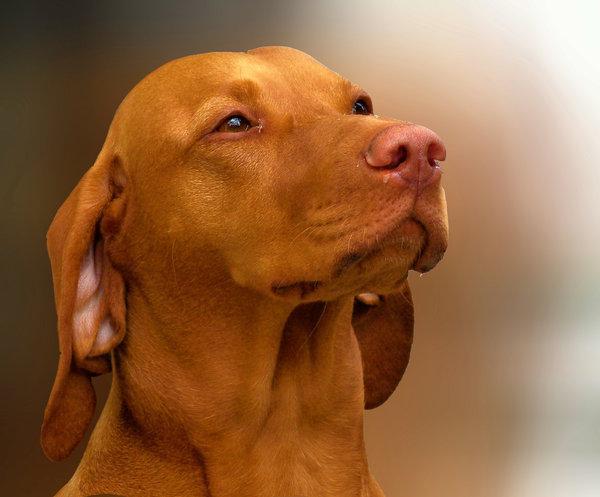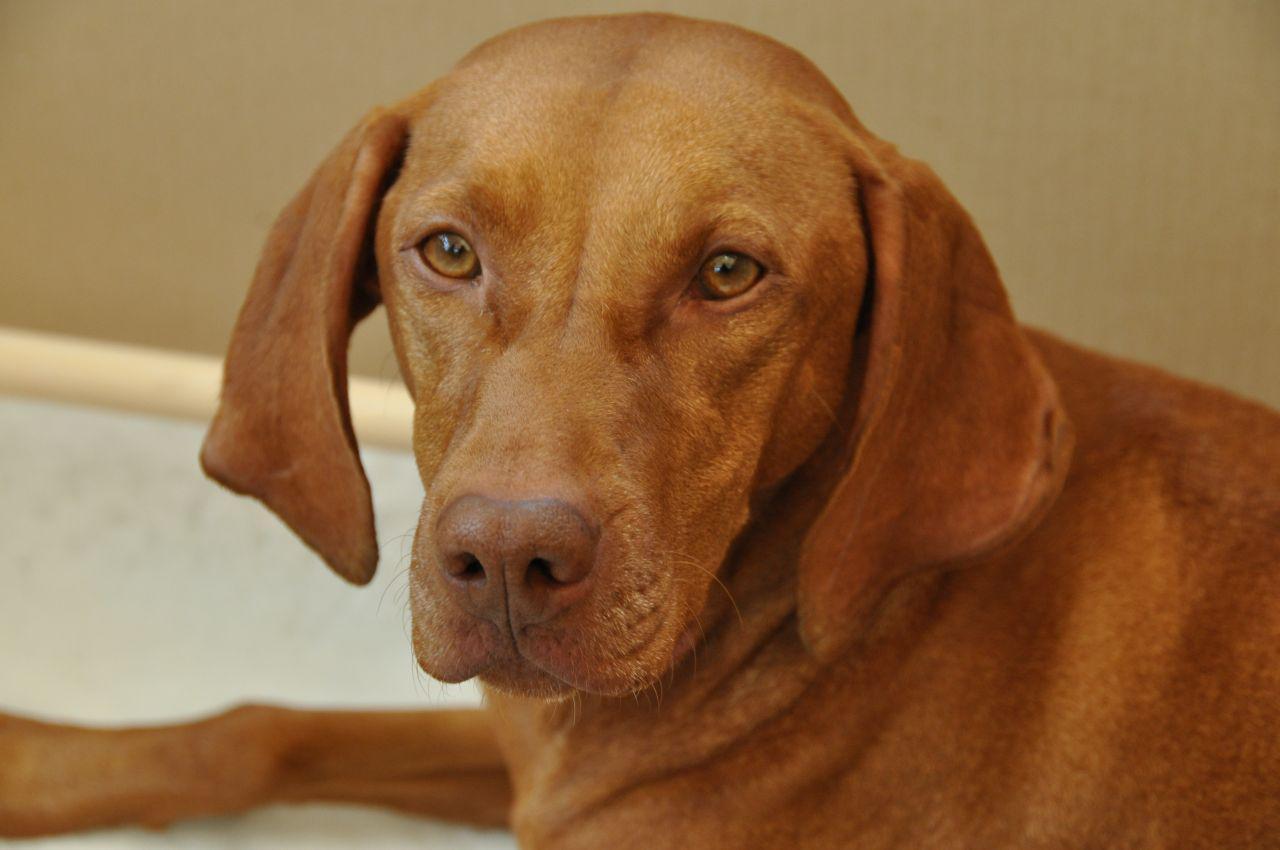The first image is the image on the left, the second image is the image on the right. Assess this claim about the two images: "The left and right image contains the same number of dogs with one puppy and one adult.". Correct or not? Answer yes or no. No. The first image is the image on the left, the second image is the image on the right. Considering the images on both sides, is "A dog is wearing a collar." valid? Answer yes or no. No. 